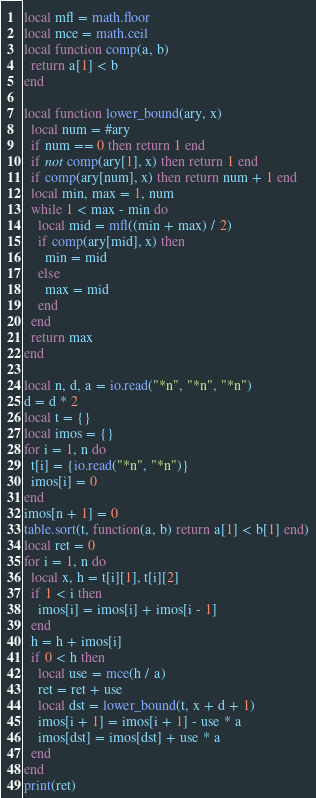Convert code to text. <code><loc_0><loc_0><loc_500><loc_500><_Lua_>local mfl = math.floor
local mce = math.ceil
local function comp(a, b)
  return a[1] < b
end

local function lower_bound(ary, x)
  local num = #ary
  if num == 0 then return 1 end
  if not comp(ary[1], x) then return 1 end
  if comp(ary[num], x) then return num + 1 end
  local min, max = 1, num
  while 1 < max - min do
    local mid = mfl((min + max) / 2)
    if comp(ary[mid], x) then
      min = mid
    else
      max = mid
    end
  end
  return max
end

local n, d, a = io.read("*n", "*n", "*n")
d = d * 2
local t = {}
local imos = {}
for i = 1, n do
  t[i] = {io.read("*n", "*n")}
  imos[i] = 0
end
imos[n + 1] = 0
table.sort(t, function(a, b) return a[1] < b[1] end)
local ret = 0
for i = 1, n do
  local x, h = t[i][1], t[i][2]
  if 1 < i then
    imos[i] = imos[i] + imos[i - 1]
  end
  h = h + imos[i]
  if 0 < h then
    local use = mce(h / a)
    ret = ret + use
    local dst = lower_bound(t, x + d + 1)
    imos[i + 1] = imos[i + 1] - use * a
    imos[dst] = imos[dst] + use * a
  end
end
print(ret)
</code> 